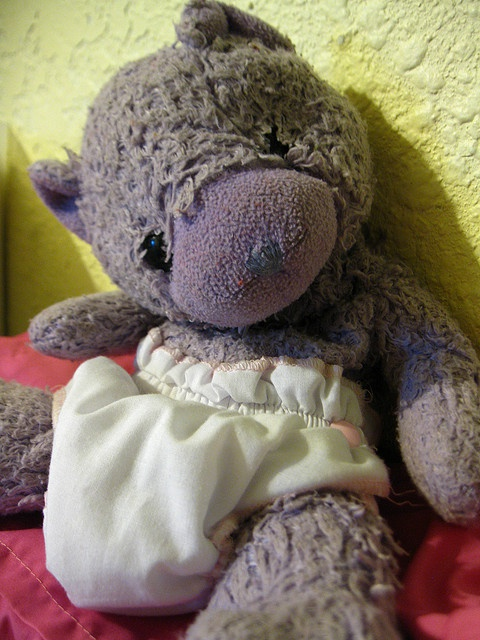Describe the objects in this image and their specific colors. I can see a teddy bear in olive, gray, darkgray, black, and lightgray tones in this image. 